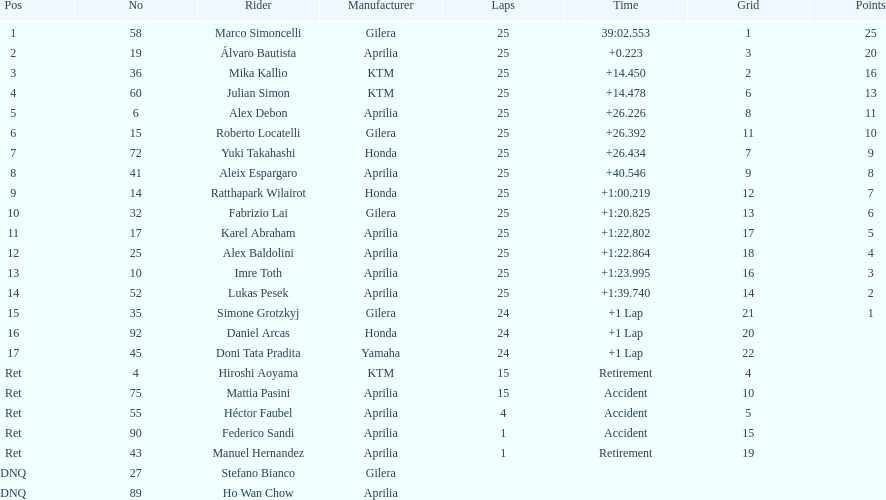Help me parse the entirety of this table. {'header': ['Pos', 'No', 'Rider', 'Manufacturer', 'Laps', 'Time', 'Grid', 'Points'], 'rows': [['1', '58', 'Marco Simoncelli', 'Gilera', '25', '39:02.553', '1', '25'], ['2', '19', 'Álvaro Bautista', 'Aprilia', '25', '+0.223', '3', '20'], ['3', '36', 'Mika Kallio', 'KTM', '25', '+14.450', '2', '16'], ['4', '60', 'Julian Simon', 'KTM', '25', '+14.478', '6', '13'], ['5', '6', 'Alex Debon', 'Aprilia', '25', '+26.226', '8', '11'], ['6', '15', 'Roberto Locatelli', 'Gilera', '25', '+26.392', '11', '10'], ['7', '72', 'Yuki Takahashi', 'Honda', '25', '+26.434', '7', '9'], ['8', '41', 'Aleix Espargaro', 'Aprilia', '25', '+40.546', '9', '8'], ['9', '14', 'Ratthapark Wilairot', 'Honda', '25', '+1:00.219', '12', '7'], ['10', '32', 'Fabrizio Lai', 'Gilera', '25', '+1:20.825', '13', '6'], ['11', '17', 'Karel Abraham', 'Aprilia', '25', '+1:22.802', '17', '5'], ['12', '25', 'Alex Baldolini', 'Aprilia', '25', '+1:22.864', '18', '4'], ['13', '10', 'Imre Toth', 'Aprilia', '25', '+1:23.995', '16', '3'], ['14', '52', 'Lukas Pesek', 'Aprilia', '25', '+1:39.740', '14', '2'], ['15', '35', 'Simone Grotzkyj', 'Gilera', '24', '+1 Lap', '21', '1'], ['16', '92', 'Daniel Arcas', 'Honda', '24', '+1 Lap', '20', ''], ['17', '45', 'Doni Tata Pradita', 'Yamaha', '24', '+1 Lap', '22', ''], ['Ret', '4', 'Hiroshi Aoyama', 'KTM', '15', 'Retirement', '4', ''], ['Ret', '75', 'Mattia Pasini', 'Aprilia', '15', 'Accident', '10', ''], ['Ret', '55', 'Héctor Faubel', 'Aprilia', '4', 'Accident', '5', ''], ['Ret', '90', 'Federico Sandi', 'Aprilia', '1', 'Accident', '15', ''], ['Ret', '43', 'Manuel Hernandez', 'Aprilia', '1', 'Retirement', '19', ''], ['DNQ', '27', 'Stefano Bianco', 'Gilera', '', '', '', ''], ['DNQ', '89', 'Ho Wan Chow', 'Aprilia', '', '', '', '']]} What is the overall count of riders? 24. 